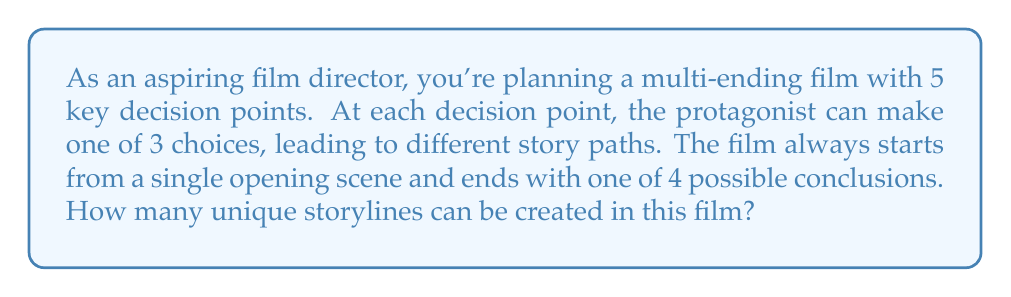Help me with this question. Let's break this down step-by-step:

1) First, we need to consider the structure of the film:
   - It starts with 1 opening scene
   - There are 5 decision points
   - At each decision point, there are 3 choices
   - There are 4 possible endings

2) The number of possible paths through the decision points can be calculated using the multiplication principle:
   $$3 \times 3 \times 3 \times 3 \times 3 = 3^5 = 243$$

3) However, this doesn't account for the different endings. After following any of these 243 paths, the story can end in one of 4 ways.

4) Therefore, we need to multiply the number of paths by the number of possible endings:
   $$243 \times 4 = 972$$

5) The single opening scene doesn't affect the number of unique storylines, as all stories start from this point.

Thus, the total number of unique storylines is 972.
Answer: 972 